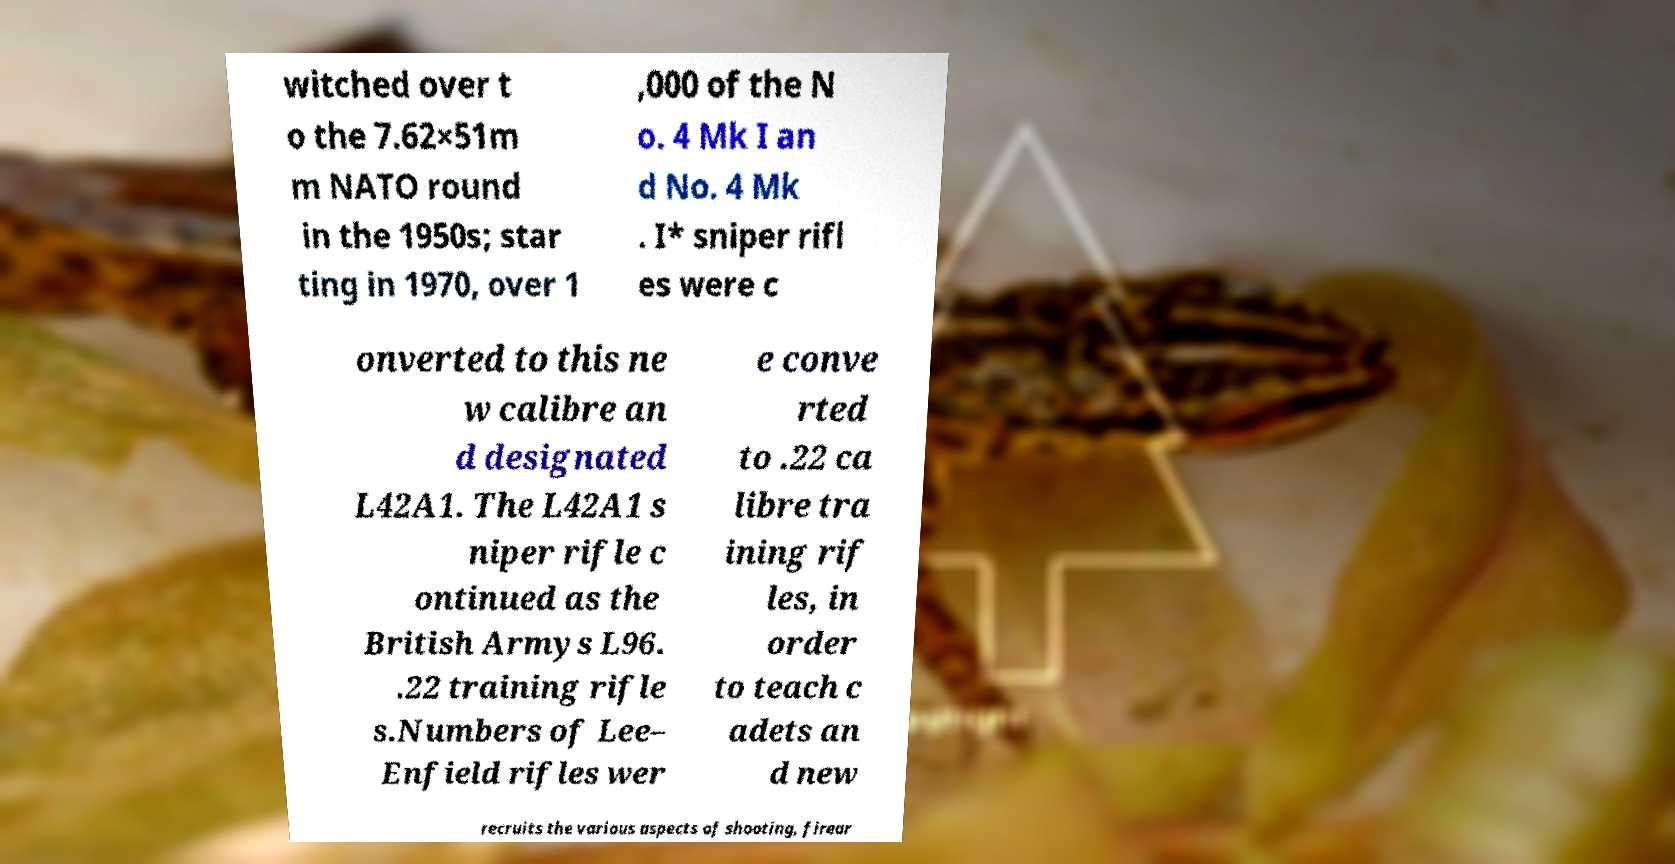I need the written content from this picture converted into text. Can you do that? witched over t o the 7.62×51m m NATO round in the 1950s; star ting in 1970, over 1 ,000 of the N o. 4 Mk I an d No. 4 Mk . I* sniper rifl es were c onverted to this ne w calibre an d designated L42A1. The L42A1 s niper rifle c ontinued as the British Armys L96. .22 training rifle s.Numbers of Lee– Enfield rifles wer e conve rted to .22 ca libre tra ining rif les, in order to teach c adets an d new recruits the various aspects of shooting, firear 